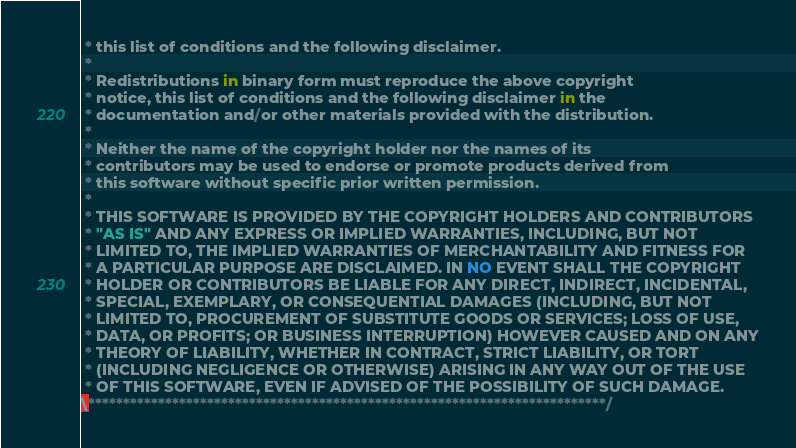Convert code to text. <code><loc_0><loc_0><loc_500><loc_500><_ObjectiveC_> * this list of conditions and the following disclaimer.
 * 
 * Redistributions in binary form must reproduce the above copyright
 * notice, this list of conditions and the following disclaimer in the
 * documentation and/or other materials provided with the distribution.
 * 
 * Neither the name of the copyright holder nor the names of its
 * contributors may be used to endorse or promote products derived from
 * this software without specific prior written permission.
 * 
 * THIS SOFTWARE IS PROVIDED BY THE COPYRIGHT HOLDERS AND CONTRIBUTORS
 * "AS IS" AND ANY EXPRESS OR IMPLIED WARRANTIES, INCLUDING, BUT NOT
 * LIMITED TO, THE IMPLIED WARRANTIES OF MERCHANTABILITY AND FITNESS FOR
 * A PARTICULAR PURPOSE ARE DISCLAIMED. IN NO EVENT SHALL THE COPYRIGHT
 * HOLDER OR CONTRIBUTORS BE LIABLE FOR ANY DIRECT, INDIRECT, INCIDENTAL,
 * SPECIAL, EXEMPLARY, OR CONSEQUENTIAL DAMAGES (INCLUDING, BUT NOT
 * LIMITED TO, PROCUREMENT OF SUBSTITUTE GOODS OR SERVICES; LOSS OF USE,
 * DATA, OR PROFITS; OR BUSINESS INTERRUPTION) HOWEVER CAUSED AND ON ANY
 * THEORY OF LIABILITY, WHETHER IN CONTRACT, STRICT LIABILITY, OR TORT
 * (INCLUDING NEGLIGENCE OR OTHERWISE) ARISING IN ANY WAY OUT OF THE USE
 * OF THIS SOFTWARE, EVEN IF ADVISED OF THE POSSIBILITY OF SUCH DAMAGE.
\**************************************************************************/
</code> 